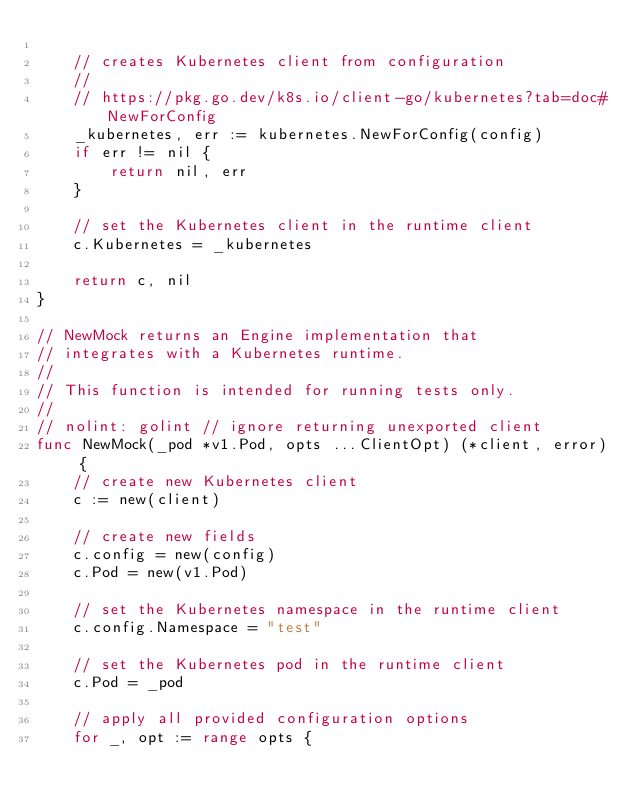Convert code to text. <code><loc_0><loc_0><loc_500><loc_500><_Go_>
	// creates Kubernetes client from configuration
	//
	// https://pkg.go.dev/k8s.io/client-go/kubernetes?tab=doc#NewForConfig
	_kubernetes, err := kubernetes.NewForConfig(config)
	if err != nil {
		return nil, err
	}

	// set the Kubernetes client in the runtime client
	c.Kubernetes = _kubernetes

	return c, nil
}

// NewMock returns an Engine implementation that
// integrates with a Kubernetes runtime.
//
// This function is intended for running tests only.
//
// nolint: golint // ignore returning unexported client
func NewMock(_pod *v1.Pod, opts ...ClientOpt) (*client, error) {
	// create new Kubernetes client
	c := new(client)

	// create new fields
	c.config = new(config)
	c.Pod = new(v1.Pod)

	// set the Kubernetes namespace in the runtime client
	c.config.Namespace = "test"

	// set the Kubernetes pod in the runtime client
	c.Pod = _pod

	// apply all provided configuration options
	for _, opt := range opts {</code> 